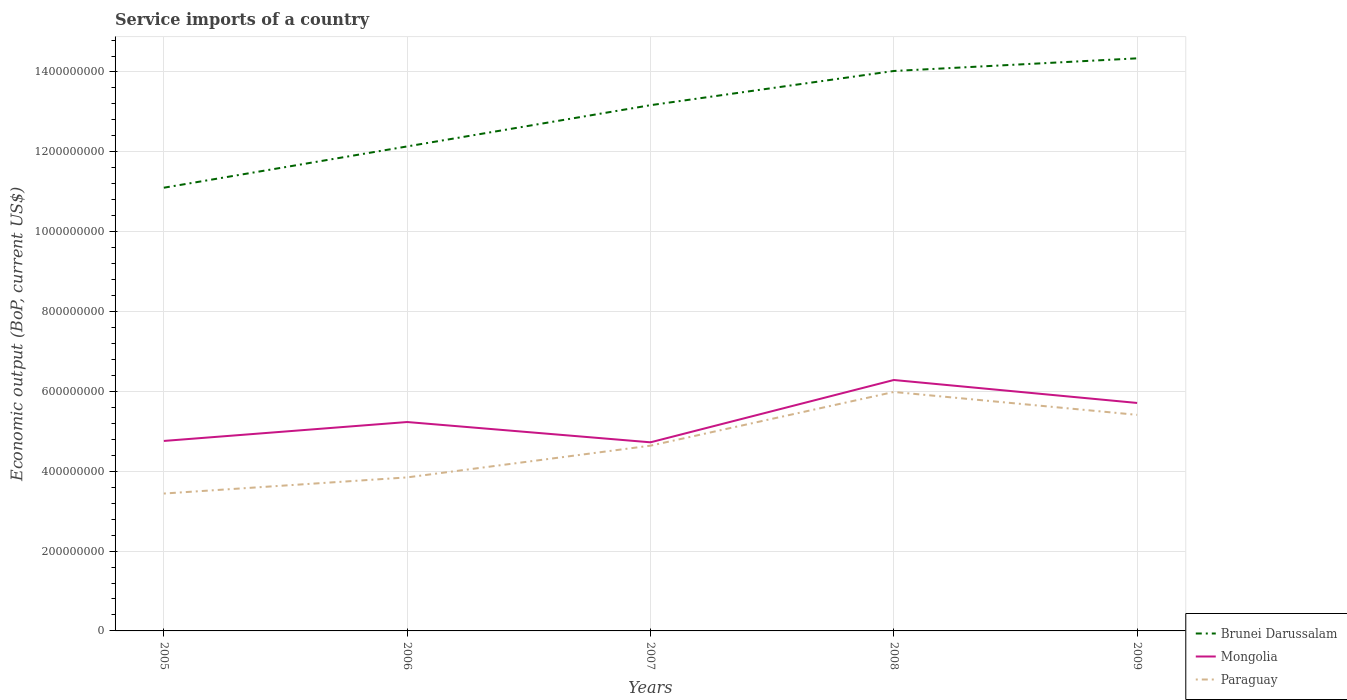How many different coloured lines are there?
Offer a terse response. 3. Does the line corresponding to Paraguay intersect with the line corresponding to Mongolia?
Provide a succinct answer. No. Across all years, what is the maximum service imports in Mongolia?
Make the answer very short. 4.72e+08. In which year was the service imports in Paraguay maximum?
Provide a short and direct response. 2005. What is the total service imports in Paraguay in the graph?
Provide a short and direct response. -1.20e+08. What is the difference between the highest and the second highest service imports in Brunei Darussalam?
Ensure brevity in your answer.  3.24e+08. What is the difference between the highest and the lowest service imports in Brunei Darussalam?
Provide a short and direct response. 3. How many lines are there?
Your answer should be compact. 3. How many years are there in the graph?
Make the answer very short. 5. Does the graph contain any zero values?
Give a very brief answer. No. Where does the legend appear in the graph?
Your answer should be very brief. Bottom right. How many legend labels are there?
Ensure brevity in your answer.  3. How are the legend labels stacked?
Keep it short and to the point. Vertical. What is the title of the graph?
Provide a succinct answer. Service imports of a country. Does "Fiji" appear as one of the legend labels in the graph?
Offer a very short reply. No. What is the label or title of the X-axis?
Offer a terse response. Years. What is the label or title of the Y-axis?
Give a very brief answer. Economic output (BoP, current US$). What is the Economic output (BoP, current US$) of Brunei Darussalam in 2005?
Offer a terse response. 1.11e+09. What is the Economic output (BoP, current US$) in Mongolia in 2005?
Provide a short and direct response. 4.76e+08. What is the Economic output (BoP, current US$) in Paraguay in 2005?
Make the answer very short. 3.44e+08. What is the Economic output (BoP, current US$) in Brunei Darussalam in 2006?
Offer a terse response. 1.21e+09. What is the Economic output (BoP, current US$) of Mongolia in 2006?
Keep it short and to the point. 5.23e+08. What is the Economic output (BoP, current US$) in Paraguay in 2006?
Ensure brevity in your answer.  3.85e+08. What is the Economic output (BoP, current US$) in Brunei Darussalam in 2007?
Make the answer very short. 1.32e+09. What is the Economic output (BoP, current US$) in Mongolia in 2007?
Keep it short and to the point. 4.72e+08. What is the Economic output (BoP, current US$) in Paraguay in 2007?
Your answer should be very brief. 4.64e+08. What is the Economic output (BoP, current US$) in Brunei Darussalam in 2008?
Offer a terse response. 1.40e+09. What is the Economic output (BoP, current US$) of Mongolia in 2008?
Make the answer very short. 6.28e+08. What is the Economic output (BoP, current US$) in Paraguay in 2008?
Provide a succinct answer. 5.99e+08. What is the Economic output (BoP, current US$) in Brunei Darussalam in 2009?
Offer a terse response. 1.43e+09. What is the Economic output (BoP, current US$) of Mongolia in 2009?
Your answer should be very brief. 5.71e+08. What is the Economic output (BoP, current US$) of Paraguay in 2009?
Your answer should be very brief. 5.41e+08. Across all years, what is the maximum Economic output (BoP, current US$) in Brunei Darussalam?
Provide a succinct answer. 1.43e+09. Across all years, what is the maximum Economic output (BoP, current US$) in Mongolia?
Your answer should be very brief. 6.28e+08. Across all years, what is the maximum Economic output (BoP, current US$) of Paraguay?
Your answer should be compact. 5.99e+08. Across all years, what is the minimum Economic output (BoP, current US$) of Brunei Darussalam?
Your response must be concise. 1.11e+09. Across all years, what is the minimum Economic output (BoP, current US$) of Mongolia?
Offer a terse response. 4.72e+08. Across all years, what is the minimum Economic output (BoP, current US$) of Paraguay?
Offer a terse response. 3.44e+08. What is the total Economic output (BoP, current US$) in Brunei Darussalam in the graph?
Make the answer very short. 6.48e+09. What is the total Economic output (BoP, current US$) in Mongolia in the graph?
Your answer should be very brief. 2.67e+09. What is the total Economic output (BoP, current US$) in Paraguay in the graph?
Offer a very short reply. 2.33e+09. What is the difference between the Economic output (BoP, current US$) of Brunei Darussalam in 2005 and that in 2006?
Offer a terse response. -1.03e+08. What is the difference between the Economic output (BoP, current US$) in Mongolia in 2005 and that in 2006?
Keep it short and to the point. -4.74e+07. What is the difference between the Economic output (BoP, current US$) of Paraguay in 2005 and that in 2006?
Offer a terse response. -4.04e+07. What is the difference between the Economic output (BoP, current US$) in Brunei Darussalam in 2005 and that in 2007?
Give a very brief answer. -2.07e+08. What is the difference between the Economic output (BoP, current US$) in Mongolia in 2005 and that in 2007?
Your answer should be compact. 3.45e+06. What is the difference between the Economic output (BoP, current US$) of Paraguay in 2005 and that in 2007?
Your response must be concise. -1.20e+08. What is the difference between the Economic output (BoP, current US$) in Brunei Darussalam in 2005 and that in 2008?
Provide a short and direct response. -2.92e+08. What is the difference between the Economic output (BoP, current US$) in Mongolia in 2005 and that in 2008?
Your answer should be compact. -1.53e+08. What is the difference between the Economic output (BoP, current US$) of Paraguay in 2005 and that in 2008?
Give a very brief answer. -2.54e+08. What is the difference between the Economic output (BoP, current US$) in Brunei Darussalam in 2005 and that in 2009?
Make the answer very short. -3.24e+08. What is the difference between the Economic output (BoP, current US$) of Mongolia in 2005 and that in 2009?
Offer a terse response. -9.51e+07. What is the difference between the Economic output (BoP, current US$) of Paraguay in 2005 and that in 2009?
Ensure brevity in your answer.  -1.97e+08. What is the difference between the Economic output (BoP, current US$) in Brunei Darussalam in 2006 and that in 2007?
Your answer should be compact. -1.03e+08. What is the difference between the Economic output (BoP, current US$) of Mongolia in 2006 and that in 2007?
Your answer should be compact. 5.08e+07. What is the difference between the Economic output (BoP, current US$) of Paraguay in 2006 and that in 2007?
Provide a succinct answer. -7.95e+07. What is the difference between the Economic output (BoP, current US$) in Brunei Darussalam in 2006 and that in 2008?
Offer a very short reply. -1.89e+08. What is the difference between the Economic output (BoP, current US$) of Mongolia in 2006 and that in 2008?
Provide a short and direct response. -1.05e+08. What is the difference between the Economic output (BoP, current US$) in Paraguay in 2006 and that in 2008?
Offer a terse response. -2.14e+08. What is the difference between the Economic output (BoP, current US$) in Brunei Darussalam in 2006 and that in 2009?
Offer a very short reply. -2.21e+08. What is the difference between the Economic output (BoP, current US$) in Mongolia in 2006 and that in 2009?
Offer a terse response. -4.78e+07. What is the difference between the Economic output (BoP, current US$) in Paraguay in 2006 and that in 2009?
Ensure brevity in your answer.  -1.57e+08. What is the difference between the Economic output (BoP, current US$) of Brunei Darussalam in 2007 and that in 2008?
Your answer should be compact. -8.57e+07. What is the difference between the Economic output (BoP, current US$) of Mongolia in 2007 and that in 2008?
Your response must be concise. -1.56e+08. What is the difference between the Economic output (BoP, current US$) in Paraguay in 2007 and that in 2008?
Provide a succinct answer. -1.35e+08. What is the difference between the Economic output (BoP, current US$) in Brunei Darussalam in 2007 and that in 2009?
Your response must be concise. -1.17e+08. What is the difference between the Economic output (BoP, current US$) in Mongolia in 2007 and that in 2009?
Your answer should be compact. -9.86e+07. What is the difference between the Economic output (BoP, current US$) of Paraguay in 2007 and that in 2009?
Keep it short and to the point. -7.72e+07. What is the difference between the Economic output (BoP, current US$) in Brunei Darussalam in 2008 and that in 2009?
Your answer should be compact. -3.17e+07. What is the difference between the Economic output (BoP, current US$) in Mongolia in 2008 and that in 2009?
Offer a very short reply. 5.75e+07. What is the difference between the Economic output (BoP, current US$) of Paraguay in 2008 and that in 2009?
Offer a terse response. 5.73e+07. What is the difference between the Economic output (BoP, current US$) in Brunei Darussalam in 2005 and the Economic output (BoP, current US$) in Mongolia in 2006?
Provide a succinct answer. 5.87e+08. What is the difference between the Economic output (BoP, current US$) in Brunei Darussalam in 2005 and the Economic output (BoP, current US$) in Paraguay in 2006?
Make the answer very short. 7.26e+08. What is the difference between the Economic output (BoP, current US$) of Mongolia in 2005 and the Economic output (BoP, current US$) of Paraguay in 2006?
Provide a short and direct response. 9.13e+07. What is the difference between the Economic output (BoP, current US$) of Brunei Darussalam in 2005 and the Economic output (BoP, current US$) of Mongolia in 2007?
Your answer should be very brief. 6.38e+08. What is the difference between the Economic output (BoP, current US$) of Brunei Darussalam in 2005 and the Economic output (BoP, current US$) of Paraguay in 2007?
Keep it short and to the point. 6.46e+08. What is the difference between the Economic output (BoP, current US$) in Mongolia in 2005 and the Economic output (BoP, current US$) in Paraguay in 2007?
Ensure brevity in your answer.  1.18e+07. What is the difference between the Economic output (BoP, current US$) in Brunei Darussalam in 2005 and the Economic output (BoP, current US$) in Mongolia in 2008?
Make the answer very short. 4.82e+08. What is the difference between the Economic output (BoP, current US$) in Brunei Darussalam in 2005 and the Economic output (BoP, current US$) in Paraguay in 2008?
Your answer should be compact. 5.12e+08. What is the difference between the Economic output (BoP, current US$) in Mongolia in 2005 and the Economic output (BoP, current US$) in Paraguay in 2008?
Your answer should be very brief. -1.23e+08. What is the difference between the Economic output (BoP, current US$) in Brunei Darussalam in 2005 and the Economic output (BoP, current US$) in Mongolia in 2009?
Provide a succinct answer. 5.39e+08. What is the difference between the Economic output (BoP, current US$) in Brunei Darussalam in 2005 and the Economic output (BoP, current US$) in Paraguay in 2009?
Keep it short and to the point. 5.69e+08. What is the difference between the Economic output (BoP, current US$) of Mongolia in 2005 and the Economic output (BoP, current US$) of Paraguay in 2009?
Provide a succinct answer. -6.54e+07. What is the difference between the Economic output (BoP, current US$) of Brunei Darussalam in 2006 and the Economic output (BoP, current US$) of Mongolia in 2007?
Offer a very short reply. 7.41e+08. What is the difference between the Economic output (BoP, current US$) in Brunei Darussalam in 2006 and the Economic output (BoP, current US$) in Paraguay in 2007?
Make the answer very short. 7.50e+08. What is the difference between the Economic output (BoP, current US$) in Mongolia in 2006 and the Economic output (BoP, current US$) in Paraguay in 2007?
Keep it short and to the point. 5.92e+07. What is the difference between the Economic output (BoP, current US$) of Brunei Darussalam in 2006 and the Economic output (BoP, current US$) of Mongolia in 2008?
Keep it short and to the point. 5.85e+08. What is the difference between the Economic output (BoP, current US$) in Brunei Darussalam in 2006 and the Economic output (BoP, current US$) in Paraguay in 2008?
Provide a short and direct response. 6.15e+08. What is the difference between the Economic output (BoP, current US$) of Mongolia in 2006 and the Economic output (BoP, current US$) of Paraguay in 2008?
Your answer should be compact. -7.53e+07. What is the difference between the Economic output (BoP, current US$) of Brunei Darussalam in 2006 and the Economic output (BoP, current US$) of Mongolia in 2009?
Offer a terse response. 6.43e+08. What is the difference between the Economic output (BoP, current US$) of Brunei Darussalam in 2006 and the Economic output (BoP, current US$) of Paraguay in 2009?
Offer a terse response. 6.72e+08. What is the difference between the Economic output (BoP, current US$) of Mongolia in 2006 and the Economic output (BoP, current US$) of Paraguay in 2009?
Your answer should be very brief. -1.80e+07. What is the difference between the Economic output (BoP, current US$) of Brunei Darussalam in 2007 and the Economic output (BoP, current US$) of Mongolia in 2008?
Offer a terse response. 6.88e+08. What is the difference between the Economic output (BoP, current US$) in Brunei Darussalam in 2007 and the Economic output (BoP, current US$) in Paraguay in 2008?
Offer a very short reply. 7.18e+08. What is the difference between the Economic output (BoP, current US$) of Mongolia in 2007 and the Economic output (BoP, current US$) of Paraguay in 2008?
Provide a short and direct response. -1.26e+08. What is the difference between the Economic output (BoP, current US$) in Brunei Darussalam in 2007 and the Economic output (BoP, current US$) in Mongolia in 2009?
Ensure brevity in your answer.  7.46e+08. What is the difference between the Economic output (BoP, current US$) of Brunei Darussalam in 2007 and the Economic output (BoP, current US$) of Paraguay in 2009?
Provide a succinct answer. 7.76e+08. What is the difference between the Economic output (BoP, current US$) in Mongolia in 2007 and the Economic output (BoP, current US$) in Paraguay in 2009?
Keep it short and to the point. -6.88e+07. What is the difference between the Economic output (BoP, current US$) in Brunei Darussalam in 2008 and the Economic output (BoP, current US$) in Mongolia in 2009?
Your answer should be compact. 8.31e+08. What is the difference between the Economic output (BoP, current US$) of Brunei Darussalam in 2008 and the Economic output (BoP, current US$) of Paraguay in 2009?
Provide a succinct answer. 8.61e+08. What is the difference between the Economic output (BoP, current US$) in Mongolia in 2008 and the Economic output (BoP, current US$) in Paraguay in 2009?
Provide a short and direct response. 8.73e+07. What is the average Economic output (BoP, current US$) of Brunei Darussalam per year?
Provide a short and direct response. 1.30e+09. What is the average Economic output (BoP, current US$) in Mongolia per year?
Your response must be concise. 5.34e+08. What is the average Economic output (BoP, current US$) of Paraguay per year?
Provide a succinct answer. 4.66e+08. In the year 2005, what is the difference between the Economic output (BoP, current US$) of Brunei Darussalam and Economic output (BoP, current US$) of Mongolia?
Provide a succinct answer. 6.34e+08. In the year 2005, what is the difference between the Economic output (BoP, current US$) of Brunei Darussalam and Economic output (BoP, current US$) of Paraguay?
Ensure brevity in your answer.  7.66e+08. In the year 2005, what is the difference between the Economic output (BoP, current US$) of Mongolia and Economic output (BoP, current US$) of Paraguay?
Your answer should be compact. 1.32e+08. In the year 2006, what is the difference between the Economic output (BoP, current US$) in Brunei Darussalam and Economic output (BoP, current US$) in Mongolia?
Offer a terse response. 6.90e+08. In the year 2006, what is the difference between the Economic output (BoP, current US$) in Brunei Darussalam and Economic output (BoP, current US$) in Paraguay?
Your answer should be very brief. 8.29e+08. In the year 2006, what is the difference between the Economic output (BoP, current US$) of Mongolia and Economic output (BoP, current US$) of Paraguay?
Offer a terse response. 1.39e+08. In the year 2007, what is the difference between the Economic output (BoP, current US$) in Brunei Darussalam and Economic output (BoP, current US$) in Mongolia?
Offer a very short reply. 8.44e+08. In the year 2007, what is the difference between the Economic output (BoP, current US$) of Brunei Darussalam and Economic output (BoP, current US$) of Paraguay?
Offer a terse response. 8.53e+08. In the year 2007, what is the difference between the Economic output (BoP, current US$) of Mongolia and Economic output (BoP, current US$) of Paraguay?
Provide a short and direct response. 8.39e+06. In the year 2008, what is the difference between the Economic output (BoP, current US$) in Brunei Darussalam and Economic output (BoP, current US$) in Mongolia?
Offer a very short reply. 7.74e+08. In the year 2008, what is the difference between the Economic output (BoP, current US$) of Brunei Darussalam and Economic output (BoP, current US$) of Paraguay?
Ensure brevity in your answer.  8.04e+08. In the year 2008, what is the difference between the Economic output (BoP, current US$) in Mongolia and Economic output (BoP, current US$) in Paraguay?
Your response must be concise. 3.00e+07. In the year 2009, what is the difference between the Economic output (BoP, current US$) of Brunei Darussalam and Economic output (BoP, current US$) of Mongolia?
Your answer should be compact. 8.63e+08. In the year 2009, what is the difference between the Economic output (BoP, current US$) in Brunei Darussalam and Economic output (BoP, current US$) in Paraguay?
Offer a terse response. 8.93e+08. In the year 2009, what is the difference between the Economic output (BoP, current US$) in Mongolia and Economic output (BoP, current US$) in Paraguay?
Keep it short and to the point. 2.98e+07. What is the ratio of the Economic output (BoP, current US$) in Brunei Darussalam in 2005 to that in 2006?
Provide a succinct answer. 0.91. What is the ratio of the Economic output (BoP, current US$) of Mongolia in 2005 to that in 2006?
Give a very brief answer. 0.91. What is the ratio of the Economic output (BoP, current US$) in Paraguay in 2005 to that in 2006?
Your response must be concise. 0.89. What is the ratio of the Economic output (BoP, current US$) of Brunei Darussalam in 2005 to that in 2007?
Provide a short and direct response. 0.84. What is the ratio of the Economic output (BoP, current US$) of Mongolia in 2005 to that in 2007?
Your response must be concise. 1.01. What is the ratio of the Economic output (BoP, current US$) of Paraguay in 2005 to that in 2007?
Provide a short and direct response. 0.74. What is the ratio of the Economic output (BoP, current US$) of Brunei Darussalam in 2005 to that in 2008?
Give a very brief answer. 0.79. What is the ratio of the Economic output (BoP, current US$) in Mongolia in 2005 to that in 2008?
Provide a succinct answer. 0.76. What is the ratio of the Economic output (BoP, current US$) in Paraguay in 2005 to that in 2008?
Your answer should be very brief. 0.57. What is the ratio of the Economic output (BoP, current US$) in Brunei Darussalam in 2005 to that in 2009?
Keep it short and to the point. 0.77. What is the ratio of the Economic output (BoP, current US$) of Mongolia in 2005 to that in 2009?
Offer a terse response. 0.83. What is the ratio of the Economic output (BoP, current US$) of Paraguay in 2005 to that in 2009?
Your answer should be very brief. 0.64. What is the ratio of the Economic output (BoP, current US$) in Brunei Darussalam in 2006 to that in 2007?
Offer a very short reply. 0.92. What is the ratio of the Economic output (BoP, current US$) in Mongolia in 2006 to that in 2007?
Provide a succinct answer. 1.11. What is the ratio of the Economic output (BoP, current US$) of Paraguay in 2006 to that in 2007?
Provide a succinct answer. 0.83. What is the ratio of the Economic output (BoP, current US$) of Brunei Darussalam in 2006 to that in 2008?
Offer a very short reply. 0.87. What is the ratio of the Economic output (BoP, current US$) of Mongolia in 2006 to that in 2008?
Ensure brevity in your answer.  0.83. What is the ratio of the Economic output (BoP, current US$) of Paraguay in 2006 to that in 2008?
Offer a very short reply. 0.64. What is the ratio of the Economic output (BoP, current US$) of Brunei Darussalam in 2006 to that in 2009?
Provide a short and direct response. 0.85. What is the ratio of the Economic output (BoP, current US$) in Mongolia in 2006 to that in 2009?
Keep it short and to the point. 0.92. What is the ratio of the Economic output (BoP, current US$) in Paraguay in 2006 to that in 2009?
Offer a terse response. 0.71. What is the ratio of the Economic output (BoP, current US$) in Brunei Darussalam in 2007 to that in 2008?
Offer a very short reply. 0.94. What is the ratio of the Economic output (BoP, current US$) of Mongolia in 2007 to that in 2008?
Make the answer very short. 0.75. What is the ratio of the Economic output (BoP, current US$) of Paraguay in 2007 to that in 2008?
Your response must be concise. 0.78. What is the ratio of the Economic output (BoP, current US$) of Brunei Darussalam in 2007 to that in 2009?
Give a very brief answer. 0.92. What is the ratio of the Economic output (BoP, current US$) of Mongolia in 2007 to that in 2009?
Provide a short and direct response. 0.83. What is the ratio of the Economic output (BoP, current US$) of Paraguay in 2007 to that in 2009?
Offer a terse response. 0.86. What is the ratio of the Economic output (BoP, current US$) in Brunei Darussalam in 2008 to that in 2009?
Your response must be concise. 0.98. What is the ratio of the Economic output (BoP, current US$) in Mongolia in 2008 to that in 2009?
Make the answer very short. 1.1. What is the ratio of the Economic output (BoP, current US$) of Paraguay in 2008 to that in 2009?
Offer a terse response. 1.11. What is the difference between the highest and the second highest Economic output (BoP, current US$) of Brunei Darussalam?
Provide a short and direct response. 3.17e+07. What is the difference between the highest and the second highest Economic output (BoP, current US$) in Mongolia?
Your answer should be compact. 5.75e+07. What is the difference between the highest and the second highest Economic output (BoP, current US$) of Paraguay?
Your response must be concise. 5.73e+07. What is the difference between the highest and the lowest Economic output (BoP, current US$) in Brunei Darussalam?
Make the answer very short. 3.24e+08. What is the difference between the highest and the lowest Economic output (BoP, current US$) of Mongolia?
Your response must be concise. 1.56e+08. What is the difference between the highest and the lowest Economic output (BoP, current US$) in Paraguay?
Keep it short and to the point. 2.54e+08. 